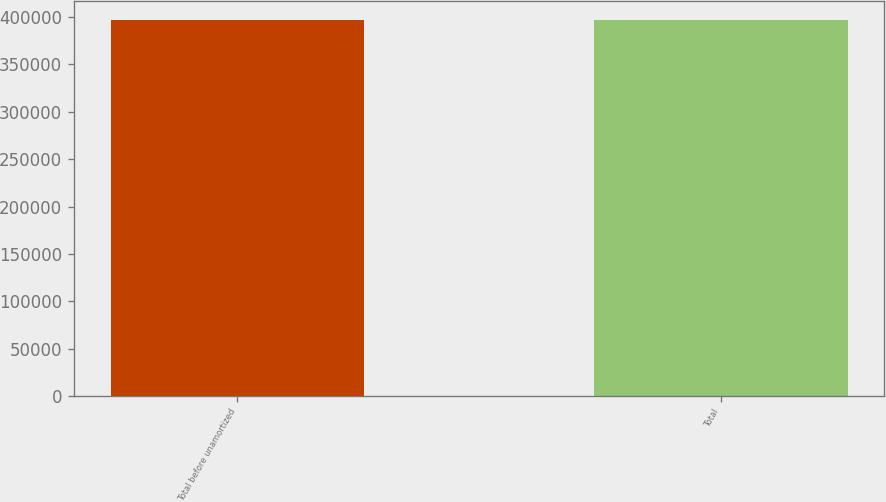Convert chart to OTSL. <chart><loc_0><loc_0><loc_500><loc_500><bar_chart><fcel>Total before unamortized<fcel>Total<nl><fcel>397000<fcel>397000<nl></chart> 